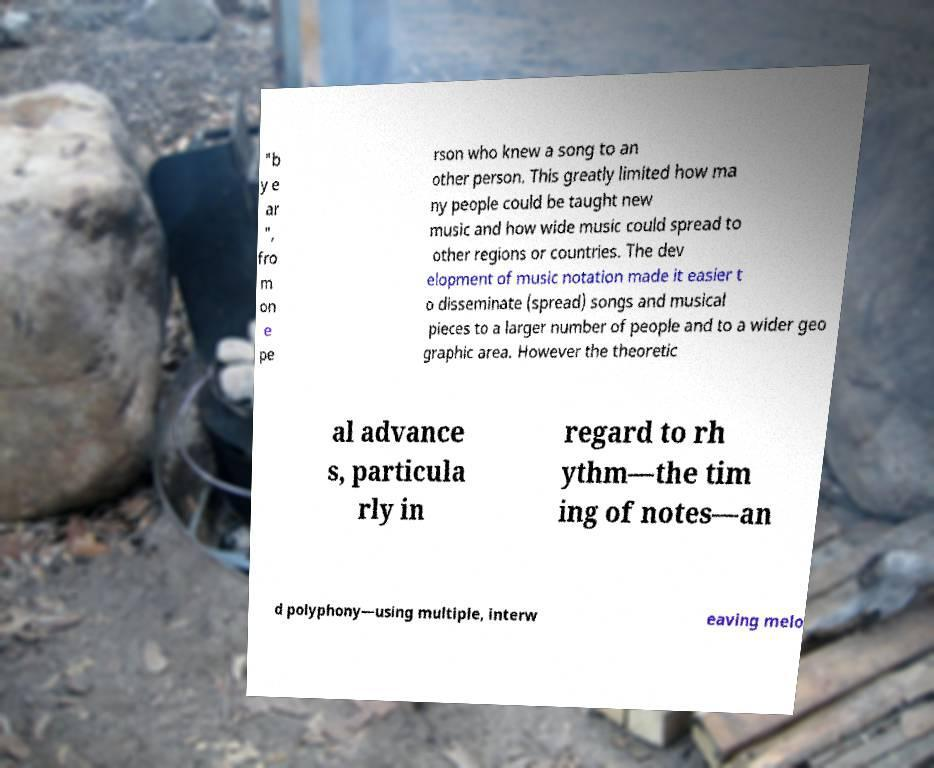Could you extract and type out the text from this image? "b y e ar ", fro m on e pe rson who knew a song to an other person. This greatly limited how ma ny people could be taught new music and how wide music could spread to other regions or countries. The dev elopment of music notation made it easier t o disseminate (spread) songs and musical pieces to a larger number of people and to a wider geo graphic area. However the theoretic al advance s, particula rly in regard to rh ythm—the tim ing of notes—an d polyphony—using multiple, interw eaving melo 